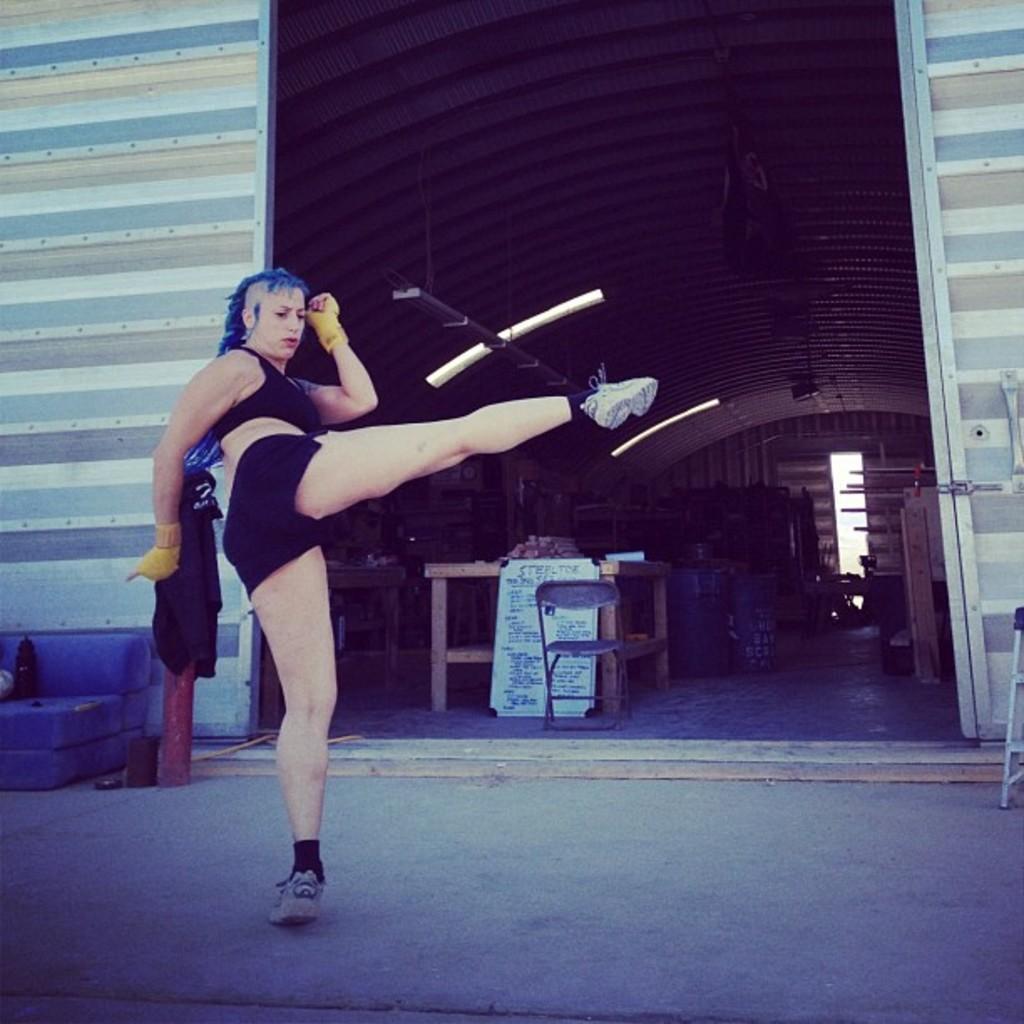Can you describe this image briefly? In the given image i can see the inside view of the shed that includes person,chair,wooden objects and lights. 